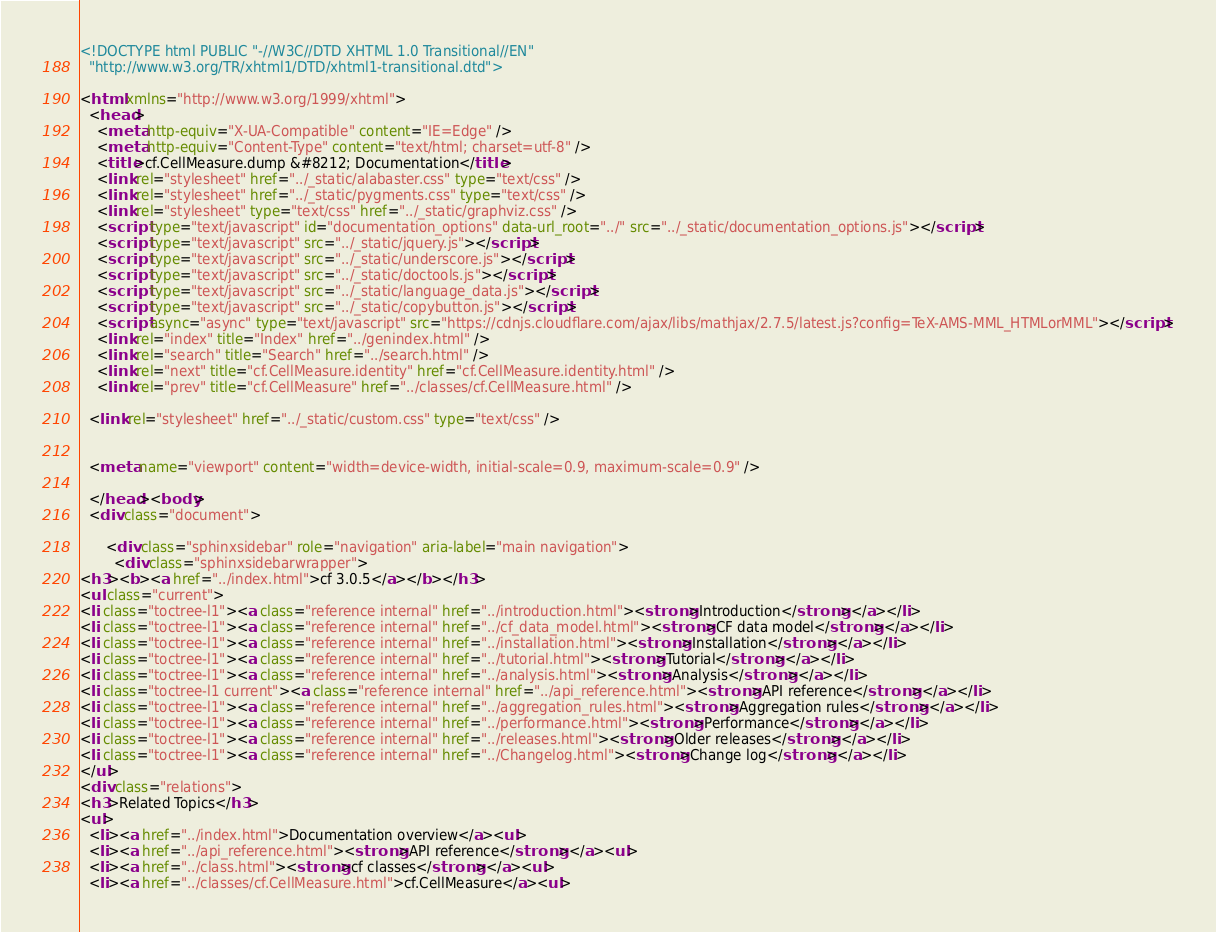<code> <loc_0><loc_0><loc_500><loc_500><_HTML_>
<!DOCTYPE html PUBLIC "-//W3C//DTD XHTML 1.0 Transitional//EN"
  "http://www.w3.org/TR/xhtml1/DTD/xhtml1-transitional.dtd">

<html xmlns="http://www.w3.org/1999/xhtml">
  <head>
    <meta http-equiv="X-UA-Compatible" content="IE=Edge" />
    <meta http-equiv="Content-Type" content="text/html; charset=utf-8" />
    <title>cf.CellMeasure.dump &#8212; Documentation</title>
    <link rel="stylesheet" href="../_static/alabaster.css" type="text/css" />
    <link rel="stylesheet" href="../_static/pygments.css" type="text/css" />
    <link rel="stylesheet" type="text/css" href="../_static/graphviz.css" />
    <script type="text/javascript" id="documentation_options" data-url_root="../" src="../_static/documentation_options.js"></script>
    <script type="text/javascript" src="../_static/jquery.js"></script>
    <script type="text/javascript" src="../_static/underscore.js"></script>
    <script type="text/javascript" src="../_static/doctools.js"></script>
    <script type="text/javascript" src="../_static/language_data.js"></script>
    <script type="text/javascript" src="../_static/copybutton.js"></script>
    <script async="async" type="text/javascript" src="https://cdnjs.cloudflare.com/ajax/libs/mathjax/2.7.5/latest.js?config=TeX-AMS-MML_HTMLorMML"></script>
    <link rel="index" title="Index" href="../genindex.html" />
    <link rel="search" title="Search" href="../search.html" />
    <link rel="next" title="cf.CellMeasure.identity" href="cf.CellMeasure.identity.html" />
    <link rel="prev" title="cf.CellMeasure" href="../classes/cf.CellMeasure.html" />
   
  <link rel="stylesheet" href="../_static/custom.css" type="text/css" />
  
  
  <meta name="viewport" content="width=device-width, initial-scale=0.9, maximum-scale=0.9" />

  </head><body>
  <div class="document">
    
      <div class="sphinxsidebar" role="navigation" aria-label="main navigation">
        <div class="sphinxsidebarwrapper">
<h3><b><a href="../index.html">cf 3.0.5</a></b></h3>
<ul class="current">
<li class="toctree-l1"><a class="reference internal" href="../introduction.html"><strong>Introduction</strong></a></li>
<li class="toctree-l1"><a class="reference internal" href="../cf_data_model.html"><strong>CF data model</strong></a></li>
<li class="toctree-l1"><a class="reference internal" href="../installation.html"><strong>Installation</strong></a></li>
<li class="toctree-l1"><a class="reference internal" href="../tutorial.html"><strong>Tutorial</strong></a></li>
<li class="toctree-l1"><a class="reference internal" href="../analysis.html"><strong>Analysis</strong></a></li>
<li class="toctree-l1 current"><a class="reference internal" href="../api_reference.html"><strong>API reference</strong></a></li>
<li class="toctree-l1"><a class="reference internal" href="../aggregation_rules.html"><strong>Aggregation rules</strong></a></li>
<li class="toctree-l1"><a class="reference internal" href="../performance.html"><strong>Performance</strong></a></li>
<li class="toctree-l1"><a class="reference internal" href="../releases.html"><strong>Older releases</strong></a></li>
<li class="toctree-l1"><a class="reference internal" href="../Changelog.html"><strong>Change log</strong></a></li>
</ul>
<div class="relations">
<h3>Related Topics</h3>
<ul>
  <li><a href="../index.html">Documentation overview</a><ul>
  <li><a href="../api_reference.html"><strong>API reference</strong></a><ul>
  <li><a href="../class.html"><strong>cf classes</strong></a><ul>
  <li><a href="../classes/cf.CellMeasure.html">cf.CellMeasure</a><ul></code> 